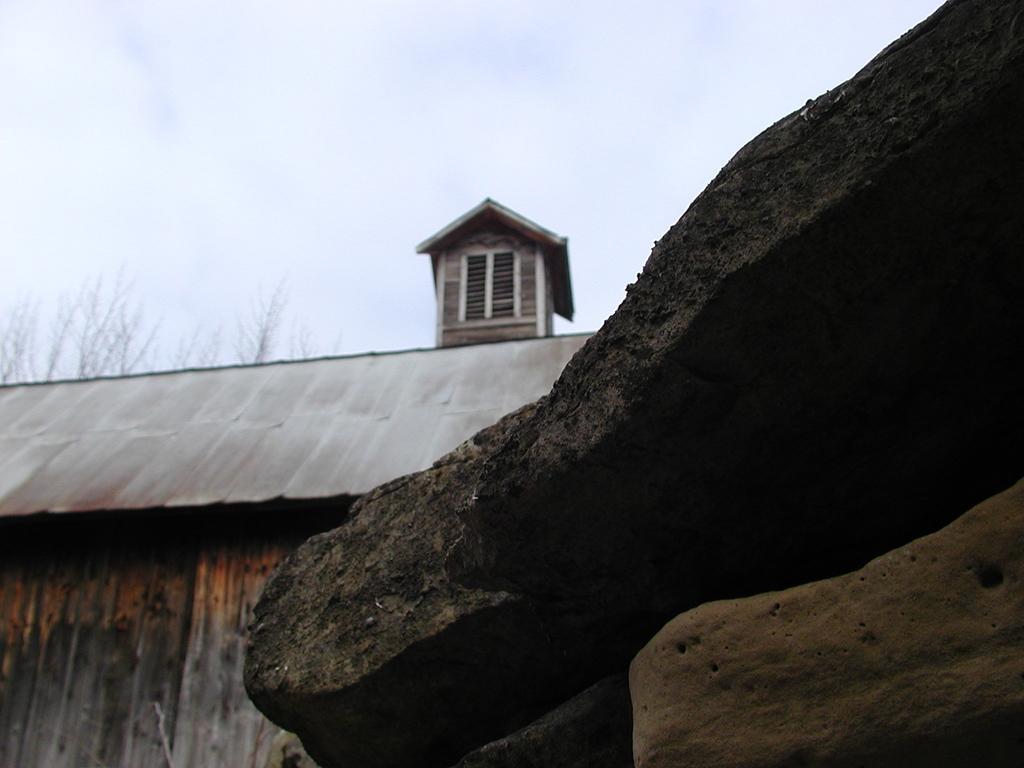Could you give a brief overview of what you see in this image? In this picture there are few rocks in the right corner and there is a wooden house in the left corner and there is a chimney above it and the sky is cloudy. 